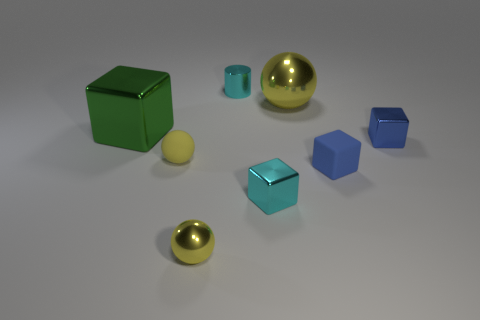The tiny rubber thing that is the same color as the large ball is what shape?
Ensure brevity in your answer.  Sphere. How many spheres are either yellow things or blue rubber objects?
Provide a short and direct response. 3. What number of rubber things are big things or cyan cylinders?
Provide a succinct answer. 0. There is another blue object that is the same shape as the blue metallic object; what is its size?
Keep it short and to the point. Small. There is a cyan shiny cylinder; does it have the same size as the yellow metal sphere that is behind the tiny blue rubber block?
Offer a very short reply. No. The large metal thing that is to the left of the metal cylinder has what shape?
Ensure brevity in your answer.  Cube. There is a large metallic thing to the left of the cyan metallic object in front of the green metal cube; what is its color?
Ensure brevity in your answer.  Green. There is a rubber thing that is the same shape as the small yellow metallic thing; what is its color?
Give a very brief answer. Yellow. What number of other small blocks have the same color as the rubber block?
Provide a succinct answer. 1. There is a small metal cylinder; is its color the same as the small metallic cube on the left side of the large shiny sphere?
Offer a very short reply. Yes. 